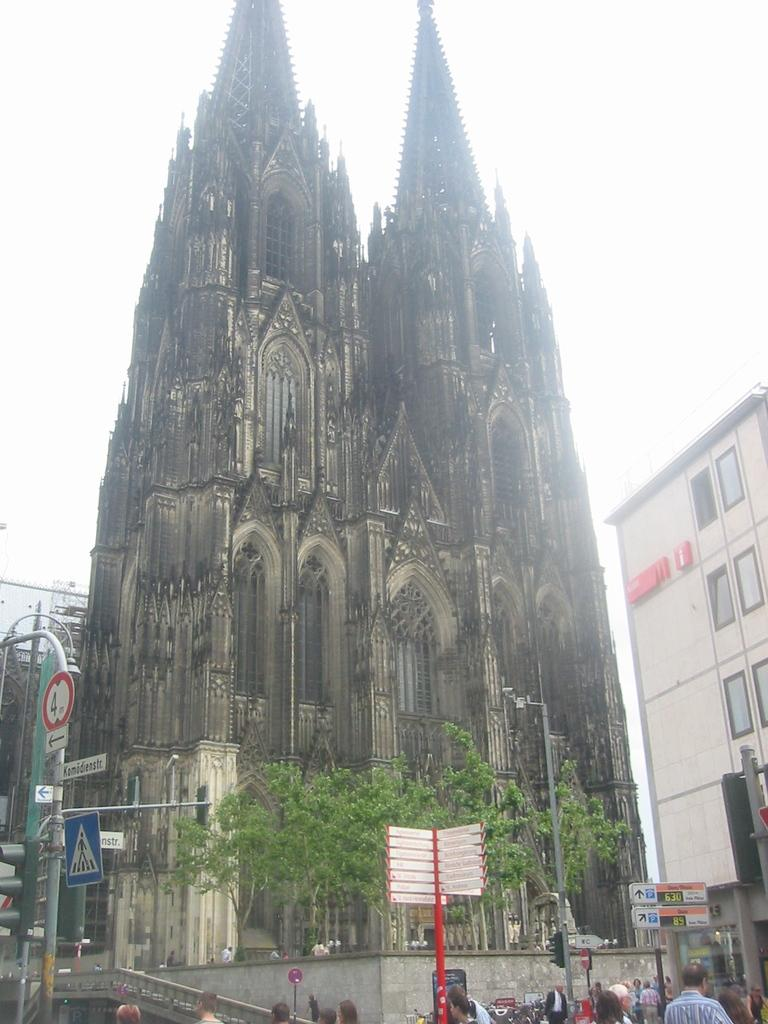What type of structures can be seen in the image? There are buildings in the image. What is located in front of the buildings? Trees are present in front of the buildings. Are there any people visible in the image? Yes, there are persons visible in the image. What other objects can be seen in the image? Sign boards and poles are visible in the image. What is visible at the top of the image? The sky is visible at the top of the image. What stands out in the middle of the image? There is a tower visible in the middle of the image. What type of light can be seen coming from the tramp in the image? There is no tramp present in the image, so there is no light coming from it. What type of iron is visible in the image? There is no iron present in the image. 